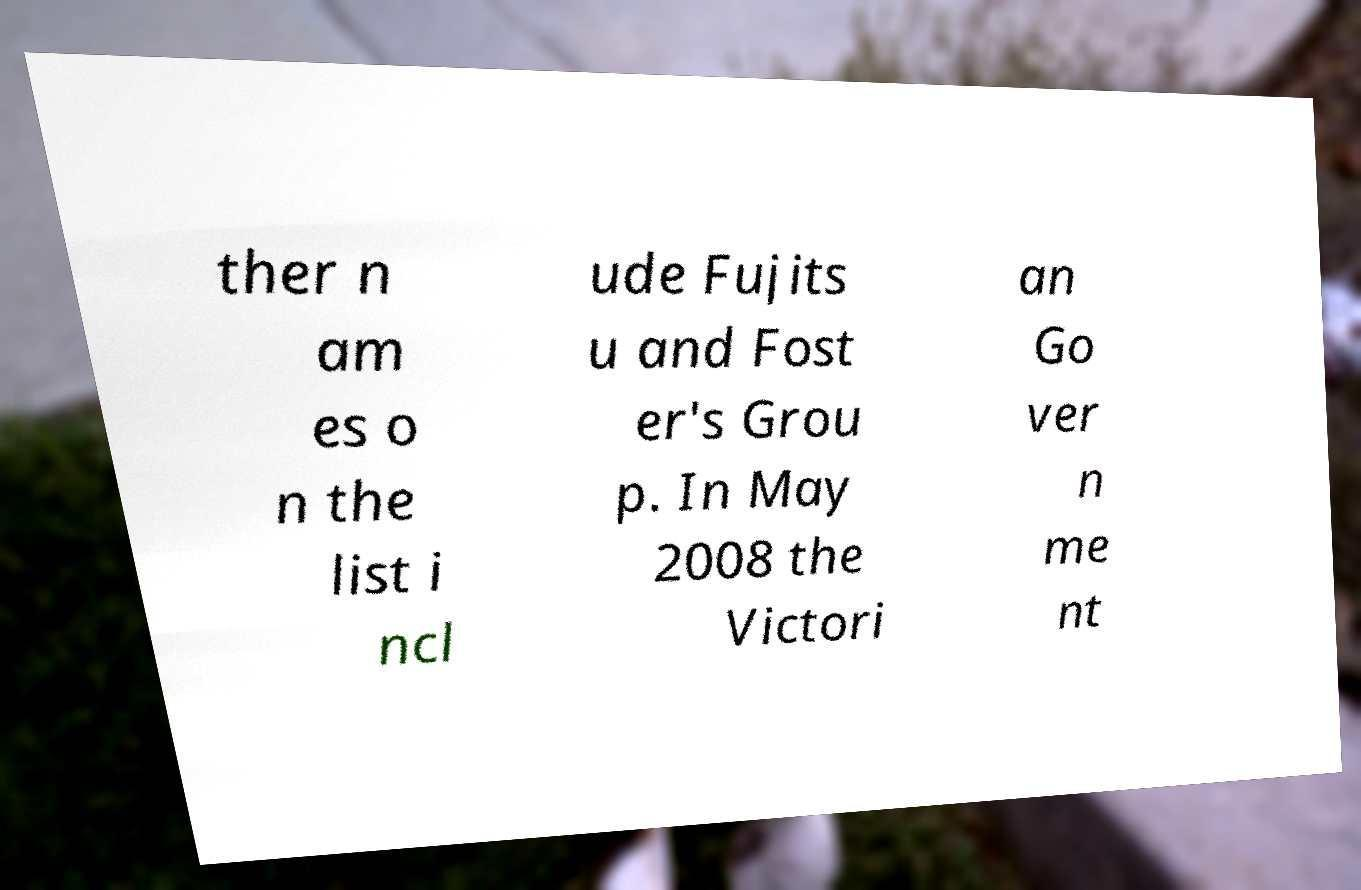Can you read and provide the text displayed in the image?This photo seems to have some interesting text. Can you extract and type it out for me? ther n am es o n the list i ncl ude Fujits u and Fost er's Grou p. In May 2008 the Victori an Go ver n me nt 